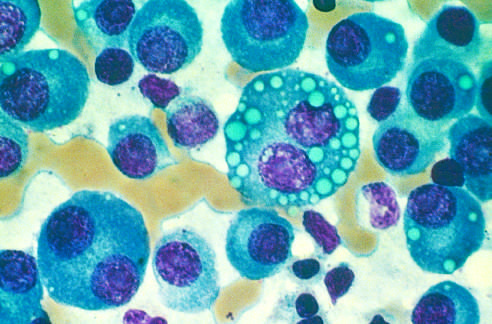re normal marrow cells largely replaced by plasma cells, including atypical forms with multiple nuclei, prominent nucleoli, and cyto-plasmic droplets containing immunoglobulin?
Answer the question using a single word or phrase. Yes 